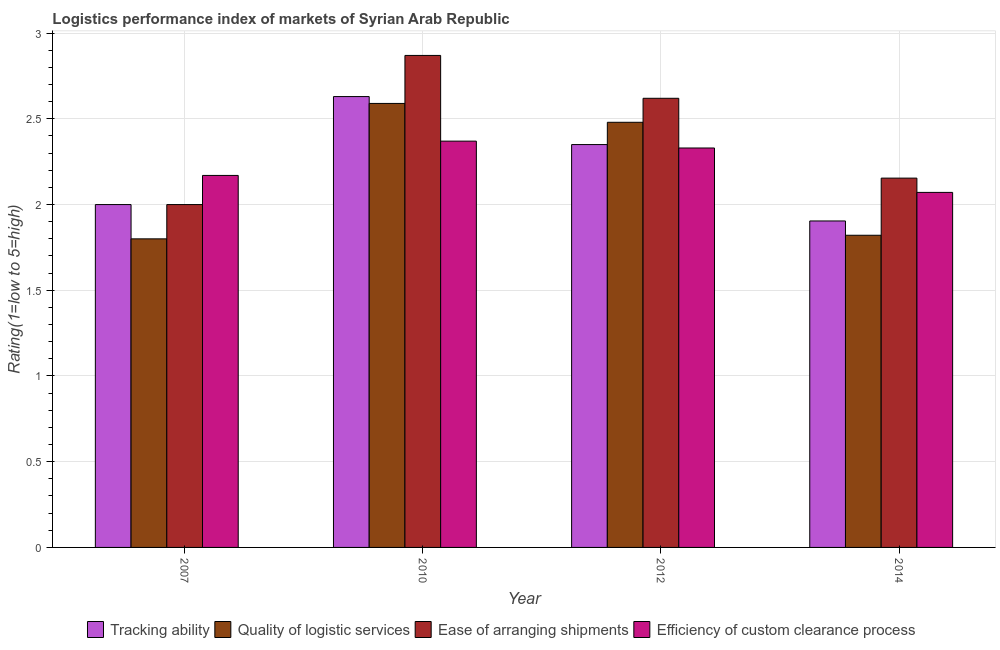How many different coloured bars are there?
Your response must be concise. 4. Are the number of bars per tick equal to the number of legend labels?
Keep it short and to the point. Yes. Are the number of bars on each tick of the X-axis equal?
Provide a short and direct response. Yes. In how many cases, is the number of bars for a given year not equal to the number of legend labels?
Your answer should be compact. 0. What is the lpi rating of ease of arranging shipments in 2010?
Offer a terse response. 2.87. Across all years, what is the maximum lpi rating of quality of logistic services?
Give a very brief answer. 2.59. Across all years, what is the minimum lpi rating of efficiency of custom clearance process?
Make the answer very short. 2.07. In which year was the lpi rating of ease of arranging shipments minimum?
Give a very brief answer. 2007. What is the total lpi rating of tracking ability in the graph?
Offer a terse response. 8.88. What is the difference between the lpi rating of tracking ability in 2007 and that in 2012?
Keep it short and to the point. -0.35. What is the difference between the lpi rating of quality of logistic services in 2010 and the lpi rating of tracking ability in 2007?
Keep it short and to the point. 0.79. What is the average lpi rating of quality of logistic services per year?
Provide a short and direct response. 2.17. In the year 2007, what is the difference between the lpi rating of efficiency of custom clearance process and lpi rating of ease of arranging shipments?
Make the answer very short. 0. In how many years, is the lpi rating of efficiency of custom clearance process greater than 2.3?
Make the answer very short. 2. What is the ratio of the lpi rating of quality of logistic services in 2007 to that in 2012?
Provide a succinct answer. 0.73. What is the difference between the highest and the second highest lpi rating of tracking ability?
Your answer should be very brief. 0.28. What is the difference between the highest and the lowest lpi rating of efficiency of custom clearance process?
Make the answer very short. 0.3. Is the sum of the lpi rating of efficiency of custom clearance process in 2012 and 2014 greater than the maximum lpi rating of quality of logistic services across all years?
Make the answer very short. Yes. What does the 2nd bar from the left in 2010 represents?
Offer a terse response. Quality of logistic services. What does the 3rd bar from the right in 2007 represents?
Provide a short and direct response. Quality of logistic services. How many bars are there?
Give a very brief answer. 16. Are all the bars in the graph horizontal?
Provide a succinct answer. No. How many years are there in the graph?
Provide a short and direct response. 4. What is the difference between two consecutive major ticks on the Y-axis?
Make the answer very short. 0.5. Are the values on the major ticks of Y-axis written in scientific E-notation?
Ensure brevity in your answer.  No. Does the graph contain any zero values?
Your response must be concise. No. Where does the legend appear in the graph?
Give a very brief answer. Bottom center. How are the legend labels stacked?
Your answer should be compact. Horizontal. What is the title of the graph?
Your answer should be compact. Logistics performance index of markets of Syrian Arab Republic. What is the label or title of the X-axis?
Your answer should be compact. Year. What is the label or title of the Y-axis?
Your answer should be compact. Rating(1=low to 5=high). What is the Rating(1=low to 5=high) in Tracking ability in 2007?
Give a very brief answer. 2. What is the Rating(1=low to 5=high) of Quality of logistic services in 2007?
Offer a terse response. 1.8. What is the Rating(1=low to 5=high) of Ease of arranging shipments in 2007?
Provide a short and direct response. 2. What is the Rating(1=low to 5=high) in Efficiency of custom clearance process in 2007?
Offer a very short reply. 2.17. What is the Rating(1=low to 5=high) in Tracking ability in 2010?
Your response must be concise. 2.63. What is the Rating(1=low to 5=high) of Quality of logistic services in 2010?
Ensure brevity in your answer.  2.59. What is the Rating(1=low to 5=high) of Ease of arranging shipments in 2010?
Ensure brevity in your answer.  2.87. What is the Rating(1=low to 5=high) of Efficiency of custom clearance process in 2010?
Your answer should be very brief. 2.37. What is the Rating(1=low to 5=high) of Tracking ability in 2012?
Your answer should be very brief. 2.35. What is the Rating(1=low to 5=high) of Quality of logistic services in 2012?
Make the answer very short. 2.48. What is the Rating(1=low to 5=high) of Ease of arranging shipments in 2012?
Your answer should be compact. 2.62. What is the Rating(1=low to 5=high) in Efficiency of custom clearance process in 2012?
Give a very brief answer. 2.33. What is the Rating(1=low to 5=high) of Tracking ability in 2014?
Your answer should be very brief. 1.9. What is the Rating(1=low to 5=high) of Quality of logistic services in 2014?
Offer a terse response. 1.82. What is the Rating(1=low to 5=high) in Ease of arranging shipments in 2014?
Offer a very short reply. 2.15. What is the Rating(1=low to 5=high) in Efficiency of custom clearance process in 2014?
Offer a very short reply. 2.07. Across all years, what is the maximum Rating(1=low to 5=high) in Tracking ability?
Offer a terse response. 2.63. Across all years, what is the maximum Rating(1=low to 5=high) in Quality of logistic services?
Your response must be concise. 2.59. Across all years, what is the maximum Rating(1=low to 5=high) of Ease of arranging shipments?
Your answer should be very brief. 2.87. Across all years, what is the maximum Rating(1=low to 5=high) of Efficiency of custom clearance process?
Keep it short and to the point. 2.37. Across all years, what is the minimum Rating(1=low to 5=high) of Tracking ability?
Provide a succinct answer. 1.9. Across all years, what is the minimum Rating(1=low to 5=high) in Ease of arranging shipments?
Your answer should be very brief. 2. Across all years, what is the minimum Rating(1=low to 5=high) in Efficiency of custom clearance process?
Provide a short and direct response. 2.07. What is the total Rating(1=low to 5=high) in Tracking ability in the graph?
Offer a very short reply. 8.88. What is the total Rating(1=low to 5=high) in Quality of logistic services in the graph?
Your answer should be very brief. 8.69. What is the total Rating(1=low to 5=high) of Ease of arranging shipments in the graph?
Your answer should be compact. 9.64. What is the total Rating(1=low to 5=high) in Efficiency of custom clearance process in the graph?
Keep it short and to the point. 8.94. What is the difference between the Rating(1=low to 5=high) in Tracking ability in 2007 and that in 2010?
Offer a very short reply. -0.63. What is the difference between the Rating(1=low to 5=high) in Quality of logistic services in 2007 and that in 2010?
Give a very brief answer. -0.79. What is the difference between the Rating(1=low to 5=high) in Ease of arranging shipments in 2007 and that in 2010?
Provide a short and direct response. -0.87. What is the difference between the Rating(1=low to 5=high) of Efficiency of custom clearance process in 2007 and that in 2010?
Provide a short and direct response. -0.2. What is the difference between the Rating(1=low to 5=high) in Tracking ability in 2007 and that in 2012?
Make the answer very short. -0.35. What is the difference between the Rating(1=low to 5=high) in Quality of logistic services in 2007 and that in 2012?
Your response must be concise. -0.68. What is the difference between the Rating(1=low to 5=high) of Ease of arranging shipments in 2007 and that in 2012?
Your response must be concise. -0.62. What is the difference between the Rating(1=low to 5=high) of Efficiency of custom clearance process in 2007 and that in 2012?
Your answer should be very brief. -0.16. What is the difference between the Rating(1=low to 5=high) in Tracking ability in 2007 and that in 2014?
Offer a terse response. 0.1. What is the difference between the Rating(1=low to 5=high) in Quality of logistic services in 2007 and that in 2014?
Your response must be concise. -0.02. What is the difference between the Rating(1=low to 5=high) of Ease of arranging shipments in 2007 and that in 2014?
Your answer should be very brief. -0.15. What is the difference between the Rating(1=low to 5=high) of Efficiency of custom clearance process in 2007 and that in 2014?
Provide a short and direct response. 0.1. What is the difference between the Rating(1=low to 5=high) in Tracking ability in 2010 and that in 2012?
Your answer should be compact. 0.28. What is the difference between the Rating(1=low to 5=high) in Quality of logistic services in 2010 and that in 2012?
Offer a very short reply. 0.11. What is the difference between the Rating(1=low to 5=high) of Tracking ability in 2010 and that in 2014?
Your answer should be compact. 0.73. What is the difference between the Rating(1=low to 5=high) in Quality of logistic services in 2010 and that in 2014?
Provide a succinct answer. 0.77. What is the difference between the Rating(1=low to 5=high) in Ease of arranging shipments in 2010 and that in 2014?
Offer a terse response. 0.72. What is the difference between the Rating(1=low to 5=high) in Efficiency of custom clearance process in 2010 and that in 2014?
Provide a succinct answer. 0.3. What is the difference between the Rating(1=low to 5=high) in Tracking ability in 2012 and that in 2014?
Offer a terse response. 0.45. What is the difference between the Rating(1=low to 5=high) in Quality of logistic services in 2012 and that in 2014?
Keep it short and to the point. 0.66. What is the difference between the Rating(1=low to 5=high) in Ease of arranging shipments in 2012 and that in 2014?
Provide a short and direct response. 0.47. What is the difference between the Rating(1=low to 5=high) in Efficiency of custom clearance process in 2012 and that in 2014?
Provide a short and direct response. 0.26. What is the difference between the Rating(1=low to 5=high) of Tracking ability in 2007 and the Rating(1=low to 5=high) of Quality of logistic services in 2010?
Provide a short and direct response. -0.59. What is the difference between the Rating(1=low to 5=high) in Tracking ability in 2007 and the Rating(1=low to 5=high) in Ease of arranging shipments in 2010?
Provide a succinct answer. -0.87. What is the difference between the Rating(1=low to 5=high) of Tracking ability in 2007 and the Rating(1=low to 5=high) of Efficiency of custom clearance process in 2010?
Offer a very short reply. -0.37. What is the difference between the Rating(1=low to 5=high) in Quality of logistic services in 2007 and the Rating(1=low to 5=high) in Ease of arranging shipments in 2010?
Your answer should be compact. -1.07. What is the difference between the Rating(1=low to 5=high) of Quality of logistic services in 2007 and the Rating(1=low to 5=high) of Efficiency of custom clearance process in 2010?
Offer a very short reply. -0.57. What is the difference between the Rating(1=low to 5=high) of Ease of arranging shipments in 2007 and the Rating(1=low to 5=high) of Efficiency of custom clearance process in 2010?
Your response must be concise. -0.37. What is the difference between the Rating(1=low to 5=high) of Tracking ability in 2007 and the Rating(1=low to 5=high) of Quality of logistic services in 2012?
Keep it short and to the point. -0.48. What is the difference between the Rating(1=low to 5=high) of Tracking ability in 2007 and the Rating(1=low to 5=high) of Ease of arranging shipments in 2012?
Your answer should be compact. -0.62. What is the difference between the Rating(1=low to 5=high) in Tracking ability in 2007 and the Rating(1=low to 5=high) in Efficiency of custom clearance process in 2012?
Your answer should be compact. -0.33. What is the difference between the Rating(1=low to 5=high) in Quality of logistic services in 2007 and the Rating(1=low to 5=high) in Ease of arranging shipments in 2012?
Offer a terse response. -0.82. What is the difference between the Rating(1=low to 5=high) of Quality of logistic services in 2007 and the Rating(1=low to 5=high) of Efficiency of custom clearance process in 2012?
Provide a succinct answer. -0.53. What is the difference between the Rating(1=low to 5=high) of Ease of arranging shipments in 2007 and the Rating(1=low to 5=high) of Efficiency of custom clearance process in 2012?
Your response must be concise. -0.33. What is the difference between the Rating(1=low to 5=high) of Tracking ability in 2007 and the Rating(1=low to 5=high) of Quality of logistic services in 2014?
Your answer should be compact. 0.18. What is the difference between the Rating(1=low to 5=high) of Tracking ability in 2007 and the Rating(1=low to 5=high) of Ease of arranging shipments in 2014?
Give a very brief answer. -0.15. What is the difference between the Rating(1=low to 5=high) of Tracking ability in 2007 and the Rating(1=low to 5=high) of Efficiency of custom clearance process in 2014?
Your answer should be compact. -0.07. What is the difference between the Rating(1=low to 5=high) in Quality of logistic services in 2007 and the Rating(1=low to 5=high) in Ease of arranging shipments in 2014?
Keep it short and to the point. -0.35. What is the difference between the Rating(1=low to 5=high) in Quality of logistic services in 2007 and the Rating(1=low to 5=high) in Efficiency of custom clearance process in 2014?
Offer a very short reply. -0.27. What is the difference between the Rating(1=low to 5=high) of Ease of arranging shipments in 2007 and the Rating(1=low to 5=high) of Efficiency of custom clearance process in 2014?
Provide a short and direct response. -0.07. What is the difference between the Rating(1=low to 5=high) in Tracking ability in 2010 and the Rating(1=low to 5=high) in Quality of logistic services in 2012?
Give a very brief answer. 0.15. What is the difference between the Rating(1=low to 5=high) in Tracking ability in 2010 and the Rating(1=low to 5=high) in Ease of arranging shipments in 2012?
Give a very brief answer. 0.01. What is the difference between the Rating(1=low to 5=high) of Quality of logistic services in 2010 and the Rating(1=low to 5=high) of Ease of arranging shipments in 2012?
Offer a terse response. -0.03. What is the difference between the Rating(1=low to 5=high) in Quality of logistic services in 2010 and the Rating(1=low to 5=high) in Efficiency of custom clearance process in 2012?
Offer a terse response. 0.26. What is the difference between the Rating(1=low to 5=high) of Ease of arranging shipments in 2010 and the Rating(1=low to 5=high) of Efficiency of custom clearance process in 2012?
Give a very brief answer. 0.54. What is the difference between the Rating(1=low to 5=high) of Tracking ability in 2010 and the Rating(1=low to 5=high) of Quality of logistic services in 2014?
Provide a short and direct response. 0.81. What is the difference between the Rating(1=low to 5=high) in Tracking ability in 2010 and the Rating(1=low to 5=high) in Ease of arranging shipments in 2014?
Ensure brevity in your answer.  0.48. What is the difference between the Rating(1=low to 5=high) in Tracking ability in 2010 and the Rating(1=low to 5=high) in Efficiency of custom clearance process in 2014?
Offer a very short reply. 0.56. What is the difference between the Rating(1=low to 5=high) of Quality of logistic services in 2010 and the Rating(1=low to 5=high) of Ease of arranging shipments in 2014?
Make the answer very short. 0.44. What is the difference between the Rating(1=low to 5=high) in Quality of logistic services in 2010 and the Rating(1=low to 5=high) in Efficiency of custom clearance process in 2014?
Your response must be concise. 0.52. What is the difference between the Rating(1=low to 5=high) of Ease of arranging shipments in 2010 and the Rating(1=low to 5=high) of Efficiency of custom clearance process in 2014?
Make the answer very short. 0.8. What is the difference between the Rating(1=low to 5=high) of Tracking ability in 2012 and the Rating(1=low to 5=high) of Quality of logistic services in 2014?
Ensure brevity in your answer.  0.53. What is the difference between the Rating(1=low to 5=high) in Tracking ability in 2012 and the Rating(1=low to 5=high) in Ease of arranging shipments in 2014?
Offer a terse response. 0.2. What is the difference between the Rating(1=low to 5=high) in Tracking ability in 2012 and the Rating(1=low to 5=high) in Efficiency of custom clearance process in 2014?
Offer a very short reply. 0.28. What is the difference between the Rating(1=low to 5=high) of Quality of logistic services in 2012 and the Rating(1=low to 5=high) of Ease of arranging shipments in 2014?
Offer a terse response. 0.33. What is the difference between the Rating(1=low to 5=high) in Quality of logistic services in 2012 and the Rating(1=low to 5=high) in Efficiency of custom clearance process in 2014?
Make the answer very short. 0.41. What is the difference between the Rating(1=low to 5=high) in Ease of arranging shipments in 2012 and the Rating(1=low to 5=high) in Efficiency of custom clearance process in 2014?
Make the answer very short. 0.55. What is the average Rating(1=low to 5=high) of Tracking ability per year?
Provide a succinct answer. 2.22. What is the average Rating(1=low to 5=high) of Quality of logistic services per year?
Provide a short and direct response. 2.17. What is the average Rating(1=low to 5=high) in Ease of arranging shipments per year?
Provide a succinct answer. 2.41. What is the average Rating(1=low to 5=high) in Efficiency of custom clearance process per year?
Your answer should be very brief. 2.24. In the year 2007, what is the difference between the Rating(1=low to 5=high) of Tracking ability and Rating(1=low to 5=high) of Efficiency of custom clearance process?
Offer a very short reply. -0.17. In the year 2007, what is the difference between the Rating(1=low to 5=high) in Quality of logistic services and Rating(1=low to 5=high) in Ease of arranging shipments?
Your response must be concise. -0.2. In the year 2007, what is the difference between the Rating(1=low to 5=high) in Quality of logistic services and Rating(1=low to 5=high) in Efficiency of custom clearance process?
Ensure brevity in your answer.  -0.37. In the year 2007, what is the difference between the Rating(1=low to 5=high) in Ease of arranging shipments and Rating(1=low to 5=high) in Efficiency of custom clearance process?
Provide a succinct answer. -0.17. In the year 2010, what is the difference between the Rating(1=low to 5=high) in Tracking ability and Rating(1=low to 5=high) in Quality of logistic services?
Your answer should be very brief. 0.04. In the year 2010, what is the difference between the Rating(1=low to 5=high) in Tracking ability and Rating(1=low to 5=high) in Ease of arranging shipments?
Your answer should be compact. -0.24. In the year 2010, what is the difference between the Rating(1=low to 5=high) of Tracking ability and Rating(1=low to 5=high) of Efficiency of custom clearance process?
Provide a succinct answer. 0.26. In the year 2010, what is the difference between the Rating(1=low to 5=high) in Quality of logistic services and Rating(1=low to 5=high) in Ease of arranging shipments?
Your answer should be very brief. -0.28. In the year 2010, what is the difference between the Rating(1=low to 5=high) in Quality of logistic services and Rating(1=low to 5=high) in Efficiency of custom clearance process?
Provide a succinct answer. 0.22. In the year 2010, what is the difference between the Rating(1=low to 5=high) in Ease of arranging shipments and Rating(1=low to 5=high) in Efficiency of custom clearance process?
Make the answer very short. 0.5. In the year 2012, what is the difference between the Rating(1=low to 5=high) of Tracking ability and Rating(1=low to 5=high) of Quality of logistic services?
Keep it short and to the point. -0.13. In the year 2012, what is the difference between the Rating(1=low to 5=high) of Tracking ability and Rating(1=low to 5=high) of Ease of arranging shipments?
Your answer should be compact. -0.27. In the year 2012, what is the difference between the Rating(1=low to 5=high) in Quality of logistic services and Rating(1=low to 5=high) in Ease of arranging shipments?
Provide a succinct answer. -0.14. In the year 2012, what is the difference between the Rating(1=low to 5=high) in Quality of logistic services and Rating(1=low to 5=high) in Efficiency of custom clearance process?
Your response must be concise. 0.15. In the year 2012, what is the difference between the Rating(1=low to 5=high) in Ease of arranging shipments and Rating(1=low to 5=high) in Efficiency of custom clearance process?
Your answer should be compact. 0.29. In the year 2014, what is the difference between the Rating(1=low to 5=high) of Tracking ability and Rating(1=low to 5=high) of Quality of logistic services?
Ensure brevity in your answer.  0.08. In the year 2014, what is the difference between the Rating(1=low to 5=high) in Quality of logistic services and Rating(1=low to 5=high) in Ease of arranging shipments?
Your answer should be compact. -0.33. In the year 2014, what is the difference between the Rating(1=low to 5=high) of Ease of arranging shipments and Rating(1=low to 5=high) of Efficiency of custom clearance process?
Ensure brevity in your answer.  0.08. What is the ratio of the Rating(1=low to 5=high) in Tracking ability in 2007 to that in 2010?
Provide a short and direct response. 0.76. What is the ratio of the Rating(1=low to 5=high) in Quality of logistic services in 2007 to that in 2010?
Provide a succinct answer. 0.69. What is the ratio of the Rating(1=low to 5=high) of Ease of arranging shipments in 2007 to that in 2010?
Provide a short and direct response. 0.7. What is the ratio of the Rating(1=low to 5=high) of Efficiency of custom clearance process in 2007 to that in 2010?
Give a very brief answer. 0.92. What is the ratio of the Rating(1=low to 5=high) in Tracking ability in 2007 to that in 2012?
Keep it short and to the point. 0.85. What is the ratio of the Rating(1=low to 5=high) of Quality of logistic services in 2007 to that in 2012?
Offer a terse response. 0.73. What is the ratio of the Rating(1=low to 5=high) of Ease of arranging shipments in 2007 to that in 2012?
Make the answer very short. 0.76. What is the ratio of the Rating(1=low to 5=high) in Efficiency of custom clearance process in 2007 to that in 2012?
Offer a very short reply. 0.93. What is the ratio of the Rating(1=low to 5=high) of Tracking ability in 2007 to that in 2014?
Your answer should be very brief. 1.05. What is the ratio of the Rating(1=low to 5=high) in Ease of arranging shipments in 2007 to that in 2014?
Offer a terse response. 0.93. What is the ratio of the Rating(1=low to 5=high) of Efficiency of custom clearance process in 2007 to that in 2014?
Offer a very short reply. 1.05. What is the ratio of the Rating(1=low to 5=high) in Tracking ability in 2010 to that in 2012?
Ensure brevity in your answer.  1.12. What is the ratio of the Rating(1=low to 5=high) in Quality of logistic services in 2010 to that in 2012?
Offer a very short reply. 1.04. What is the ratio of the Rating(1=low to 5=high) of Ease of arranging shipments in 2010 to that in 2012?
Your answer should be very brief. 1.1. What is the ratio of the Rating(1=low to 5=high) in Efficiency of custom clearance process in 2010 to that in 2012?
Provide a succinct answer. 1.02. What is the ratio of the Rating(1=low to 5=high) of Tracking ability in 2010 to that in 2014?
Offer a terse response. 1.38. What is the ratio of the Rating(1=low to 5=high) in Quality of logistic services in 2010 to that in 2014?
Keep it short and to the point. 1.42. What is the ratio of the Rating(1=low to 5=high) in Ease of arranging shipments in 2010 to that in 2014?
Your answer should be compact. 1.33. What is the ratio of the Rating(1=low to 5=high) in Efficiency of custom clearance process in 2010 to that in 2014?
Provide a short and direct response. 1.14. What is the ratio of the Rating(1=low to 5=high) of Tracking ability in 2012 to that in 2014?
Your response must be concise. 1.23. What is the ratio of the Rating(1=low to 5=high) of Quality of logistic services in 2012 to that in 2014?
Keep it short and to the point. 1.36. What is the ratio of the Rating(1=low to 5=high) in Ease of arranging shipments in 2012 to that in 2014?
Give a very brief answer. 1.22. What is the ratio of the Rating(1=low to 5=high) in Efficiency of custom clearance process in 2012 to that in 2014?
Offer a terse response. 1.13. What is the difference between the highest and the second highest Rating(1=low to 5=high) of Tracking ability?
Offer a terse response. 0.28. What is the difference between the highest and the second highest Rating(1=low to 5=high) of Quality of logistic services?
Give a very brief answer. 0.11. What is the difference between the highest and the lowest Rating(1=low to 5=high) in Tracking ability?
Provide a short and direct response. 0.73. What is the difference between the highest and the lowest Rating(1=low to 5=high) of Quality of logistic services?
Make the answer very short. 0.79. What is the difference between the highest and the lowest Rating(1=low to 5=high) in Ease of arranging shipments?
Give a very brief answer. 0.87. What is the difference between the highest and the lowest Rating(1=low to 5=high) in Efficiency of custom clearance process?
Make the answer very short. 0.3. 